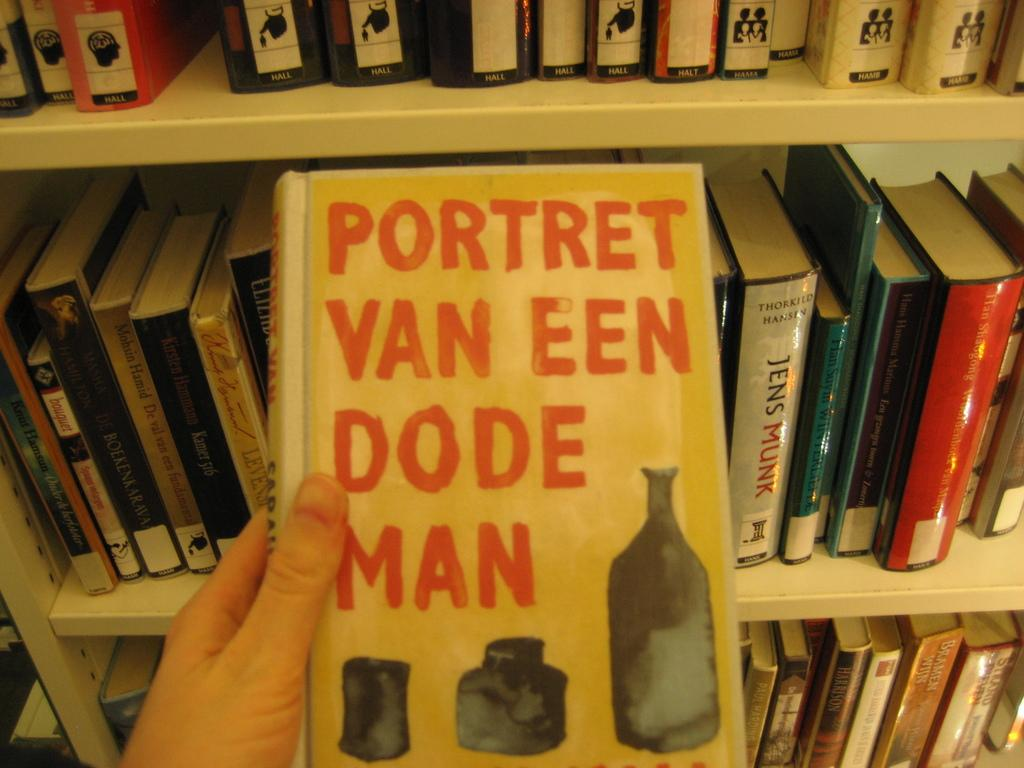<image>
Describe the image concisely. A library book shelf with a hand holding a book that reads Portret Van Een Dode Man on the cover 